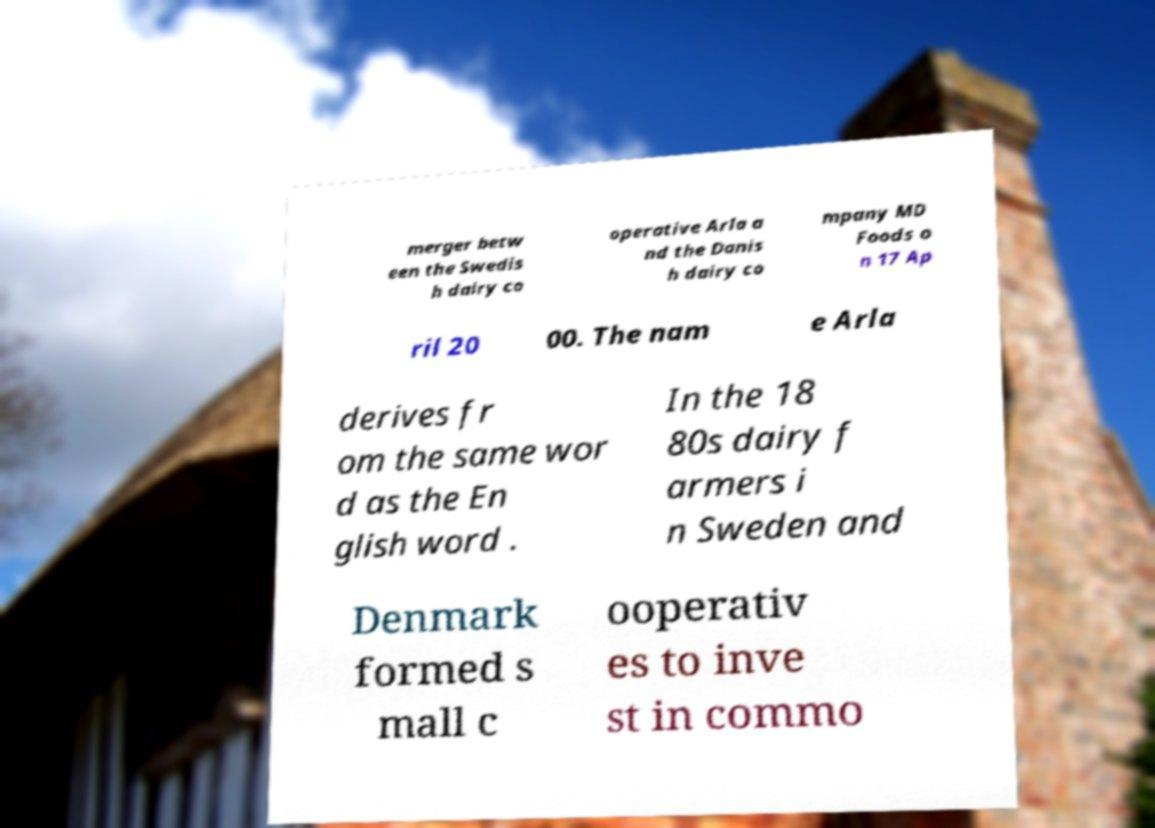Could you extract and type out the text from this image? merger betw een the Swedis h dairy co operative Arla a nd the Danis h dairy co mpany MD Foods o n 17 Ap ril 20 00. The nam e Arla derives fr om the same wor d as the En glish word . In the 18 80s dairy f armers i n Sweden and Denmark formed s mall c ooperativ es to inve st in commo 